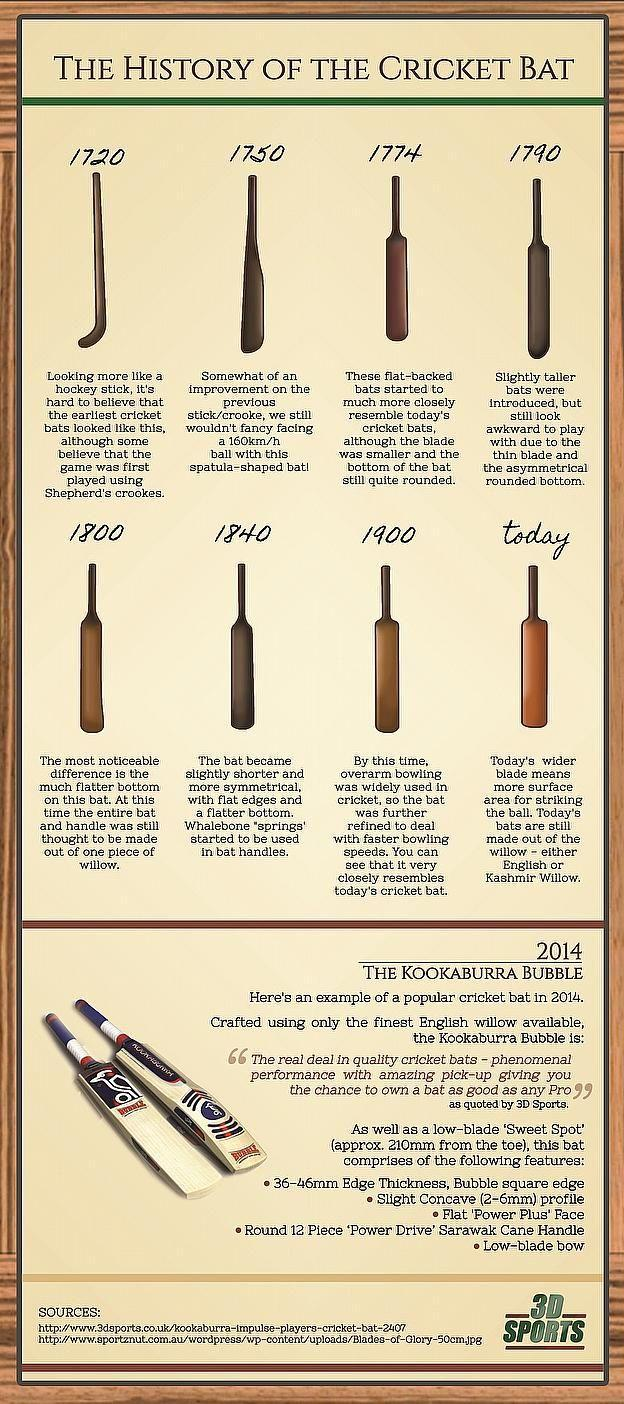When did the cricket bat start resembling a wooden turner?
Answer the question with a short phrase. 1750 What is the brand name written on the cricket bat? Kookaburra During which period the did the cricket bat resemble a pusher? 1720 